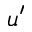Convert formula to latex. <formula><loc_0><loc_0><loc_500><loc_500>u ^ { \prime }</formula> 